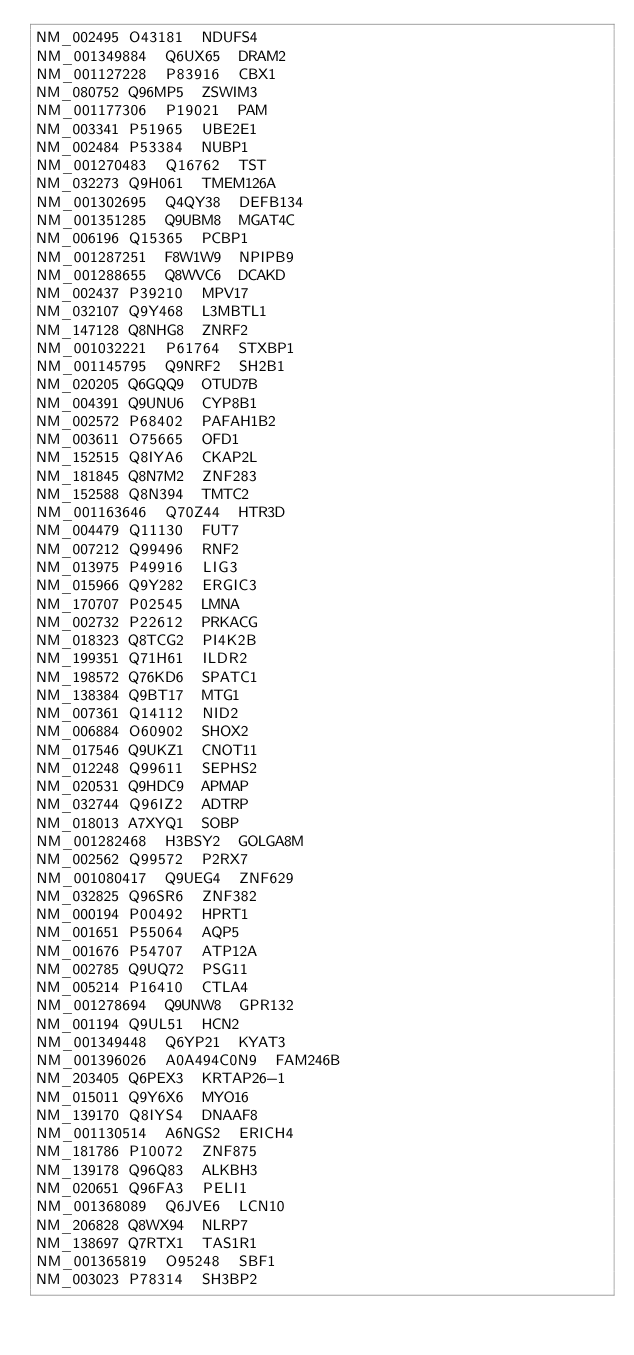Convert code to text. <code><loc_0><loc_0><loc_500><loc_500><_SQL_>NM_002495	O43181	NDUFS4
NM_001349884	Q6UX65	DRAM2
NM_001127228	P83916	CBX1
NM_080752	Q96MP5	ZSWIM3
NM_001177306	P19021	PAM
NM_003341	P51965	UBE2E1
NM_002484	P53384	NUBP1
NM_001270483	Q16762	TST
NM_032273	Q9H061	TMEM126A
NM_001302695	Q4QY38	DEFB134
NM_001351285	Q9UBM8	MGAT4C
NM_006196	Q15365	PCBP1
NM_001287251	F8W1W9	NPIPB9
NM_001288655	Q8WVC6	DCAKD
NM_002437	P39210	MPV17
NM_032107	Q9Y468	L3MBTL1
NM_147128	Q8NHG8	ZNRF2
NM_001032221	P61764	STXBP1
NM_001145795	Q9NRF2	SH2B1
NM_020205	Q6GQQ9	OTUD7B
NM_004391	Q9UNU6	CYP8B1
NM_002572	P68402	PAFAH1B2
NM_003611	O75665	OFD1
NM_152515	Q8IYA6	CKAP2L
NM_181845	Q8N7M2	ZNF283
NM_152588	Q8N394	TMTC2
NM_001163646	Q70Z44	HTR3D
NM_004479	Q11130	FUT7
NM_007212	Q99496	RNF2
NM_013975	P49916	LIG3
NM_015966	Q9Y282	ERGIC3
NM_170707	P02545	LMNA
NM_002732	P22612	PRKACG
NM_018323	Q8TCG2	PI4K2B
NM_199351	Q71H61	ILDR2
NM_198572	Q76KD6	SPATC1
NM_138384	Q9BT17	MTG1
NM_007361	Q14112	NID2
NM_006884	O60902	SHOX2
NM_017546	Q9UKZ1	CNOT11
NM_012248	Q99611	SEPHS2
NM_020531	Q9HDC9	APMAP
NM_032744	Q96IZ2	ADTRP
NM_018013	A7XYQ1	SOBP
NM_001282468	H3BSY2	GOLGA8M
NM_002562	Q99572	P2RX7
NM_001080417	Q9UEG4	ZNF629
NM_032825	Q96SR6	ZNF382
NM_000194	P00492	HPRT1
NM_001651	P55064	AQP5
NM_001676	P54707	ATP12A
NM_002785	Q9UQ72	PSG11
NM_005214	P16410	CTLA4
NM_001278694	Q9UNW8	GPR132
NM_001194	Q9UL51	HCN2
NM_001349448	Q6YP21	KYAT3
NM_001396026	A0A494C0N9	FAM246B
NM_203405	Q6PEX3	KRTAP26-1
NM_015011	Q9Y6X6	MYO16
NM_139170	Q8IYS4	DNAAF8
NM_001130514	A6NGS2	ERICH4
NM_181786	P10072	ZNF875
NM_139178	Q96Q83	ALKBH3
NM_020651	Q96FA3	PELI1
NM_001368089	Q6JVE6	LCN10
NM_206828	Q8WX94	NLRP7
NM_138697	Q7RTX1	TAS1R1
NM_001365819	O95248	SBF1
NM_003023	P78314	SH3BP2</code> 